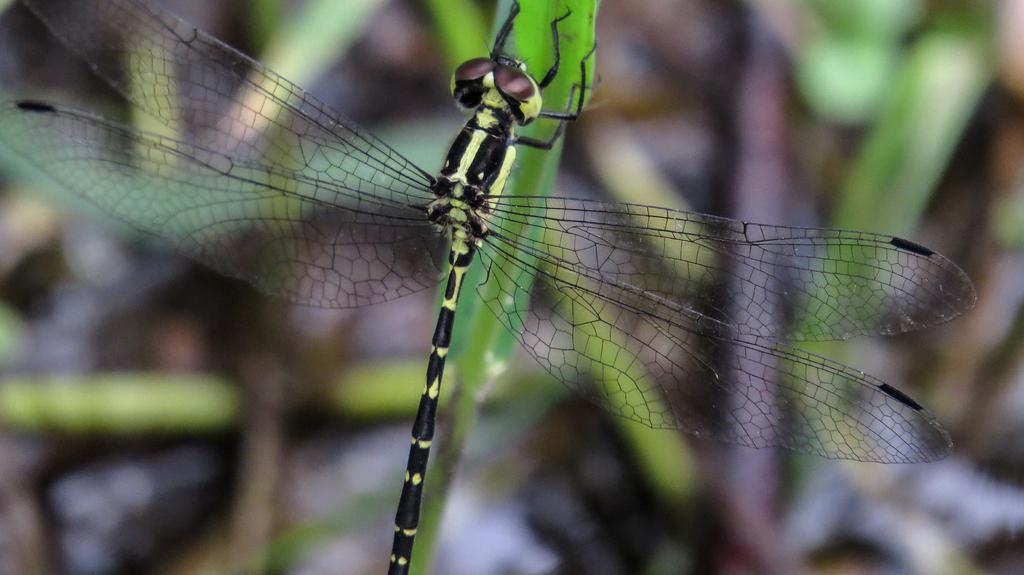Please provide a concise description of this image. In this image, we can see a dragonfly on blur background. 